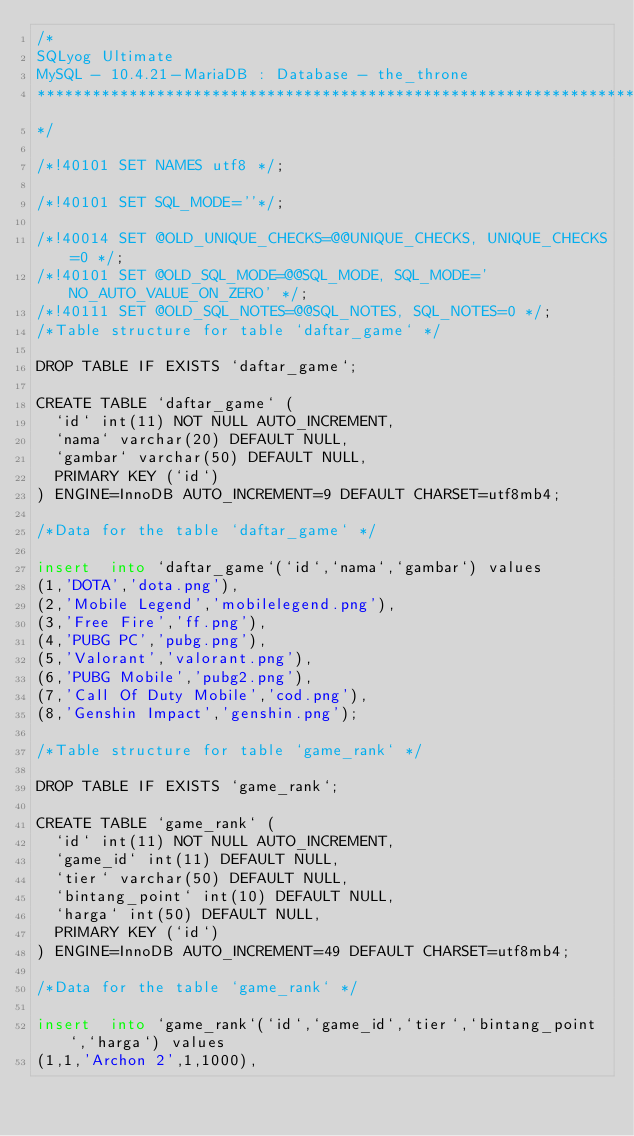Convert code to text. <code><loc_0><loc_0><loc_500><loc_500><_SQL_>/*
SQLyog Ultimate
MySQL - 10.4.21-MariaDB : Database - the_throne
*********************************************************************
*/

/*!40101 SET NAMES utf8 */;

/*!40101 SET SQL_MODE=''*/;

/*!40014 SET @OLD_UNIQUE_CHECKS=@@UNIQUE_CHECKS, UNIQUE_CHECKS=0 */;
/*!40101 SET @OLD_SQL_MODE=@@SQL_MODE, SQL_MODE='NO_AUTO_VALUE_ON_ZERO' */;
/*!40111 SET @OLD_SQL_NOTES=@@SQL_NOTES, SQL_NOTES=0 */;
/*Table structure for table `daftar_game` */

DROP TABLE IF EXISTS `daftar_game`;

CREATE TABLE `daftar_game` (
  `id` int(11) NOT NULL AUTO_INCREMENT,
  `nama` varchar(20) DEFAULT NULL,
  `gambar` varchar(50) DEFAULT NULL,
  PRIMARY KEY (`id`)
) ENGINE=InnoDB AUTO_INCREMENT=9 DEFAULT CHARSET=utf8mb4;

/*Data for the table `daftar_game` */

insert  into `daftar_game`(`id`,`nama`,`gambar`) values 
(1,'DOTA','dota.png'),
(2,'Mobile Legend','mobilelegend.png'),
(3,'Free Fire','ff.png'),
(4,'PUBG PC','pubg.png'),
(5,'Valorant','valorant.png'),
(6,'PUBG Mobile','pubg2.png'),
(7,'Call Of Duty Mobile','cod.png'),
(8,'Genshin Impact','genshin.png');

/*Table structure for table `game_rank` */

DROP TABLE IF EXISTS `game_rank`;

CREATE TABLE `game_rank` (
  `id` int(11) NOT NULL AUTO_INCREMENT,
  `game_id` int(11) DEFAULT NULL,
  `tier` varchar(50) DEFAULT NULL,
  `bintang_point` int(10) DEFAULT NULL,
  `harga` int(50) DEFAULT NULL,
  PRIMARY KEY (`id`)
) ENGINE=InnoDB AUTO_INCREMENT=49 DEFAULT CHARSET=utf8mb4;

/*Data for the table `game_rank` */

insert  into `game_rank`(`id`,`game_id`,`tier`,`bintang_point`,`harga`) values 
(1,1,'Archon 2',1,1000),</code> 